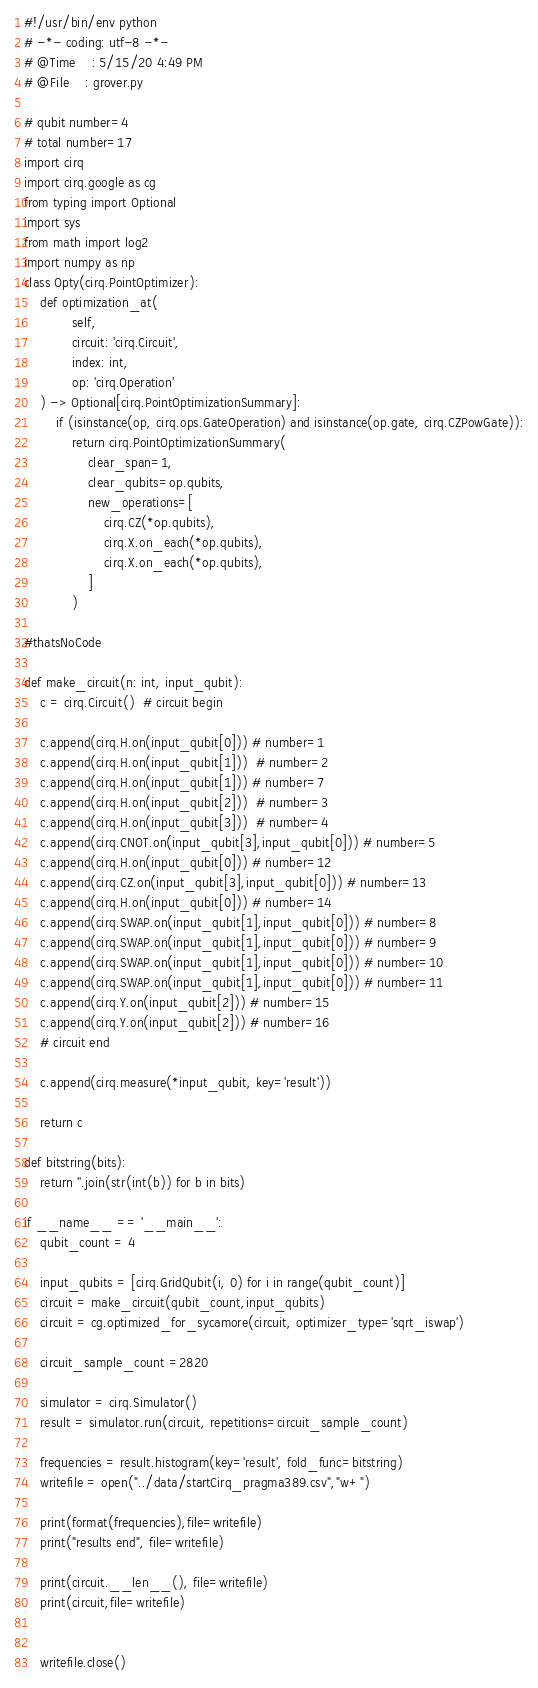<code> <loc_0><loc_0><loc_500><loc_500><_Python_>#!/usr/bin/env python
# -*- coding: utf-8 -*-
# @Time    : 5/15/20 4:49 PM
# @File    : grover.py

# qubit number=4
# total number=17
import cirq
import cirq.google as cg
from typing import Optional
import sys
from math import log2
import numpy as np
class Opty(cirq.PointOptimizer):
    def optimization_at(
            self,
            circuit: 'cirq.Circuit',
            index: int,
            op: 'cirq.Operation'
    ) -> Optional[cirq.PointOptimizationSummary]:
        if (isinstance(op, cirq.ops.GateOperation) and isinstance(op.gate, cirq.CZPowGate)):
            return cirq.PointOptimizationSummary(
                clear_span=1,
                clear_qubits=op.qubits, 
                new_operations=[
                    cirq.CZ(*op.qubits),
                    cirq.X.on_each(*op.qubits),
                    cirq.X.on_each(*op.qubits),
                ]
            )

#thatsNoCode

def make_circuit(n: int, input_qubit):
    c = cirq.Circuit()  # circuit begin

    c.append(cirq.H.on(input_qubit[0])) # number=1
    c.append(cirq.H.on(input_qubit[1]))  # number=2
    c.append(cirq.H.on(input_qubit[1])) # number=7
    c.append(cirq.H.on(input_qubit[2]))  # number=3
    c.append(cirq.H.on(input_qubit[3]))  # number=4
    c.append(cirq.CNOT.on(input_qubit[3],input_qubit[0])) # number=5
    c.append(cirq.H.on(input_qubit[0])) # number=12
    c.append(cirq.CZ.on(input_qubit[3],input_qubit[0])) # number=13
    c.append(cirq.H.on(input_qubit[0])) # number=14
    c.append(cirq.SWAP.on(input_qubit[1],input_qubit[0])) # number=8
    c.append(cirq.SWAP.on(input_qubit[1],input_qubit[0])) # number=9
    c.append(cirq.SWAP.on(input_qubit[1],input_qubit[0])) # number=10
    c.append(cirq.SWAP.on(input_qubit[1],input_qubit[0])) # number=11
    c.append(cirq.Y.on(input_qubit[2])) # number=15
    c.append(cirq.Y.on(input_qubit[2])) # number=16
    # circuit end

    c.append(cirq.measure(*input_qubit, key='result'))

    return c

def bitstring(bits):
    return ''.join(str(int(b)) for b in bits)

if __name__ == '__main__':
    qubit_count = 4

    input_qubits = [cirq.GridQubit(i, 0) for i in range(qubit_count)]
    circuit = make_circuit(qubit_count,input_qubits)
    circuit = cg.optimized_for_sycamore(circuit, optimizer_type='sqrt_iswap')

    circuit_sample_count =2820

    simulator = cirq.Simulator()
    result = simulator.run(circuit, repetitions=circuit_sample_count)

    frequencies = result.histogram(key='result', fold_func=bitstring)
    writefile = open("../data/startCirq_pragma389.csv","w+")

    print(format(frequencies),file=writefile)
    print("results end", file=writefile)

    print(circuit.__len__(), file=writefile)
    print(circuit,file=writefile)


    writefile.close()</code> 